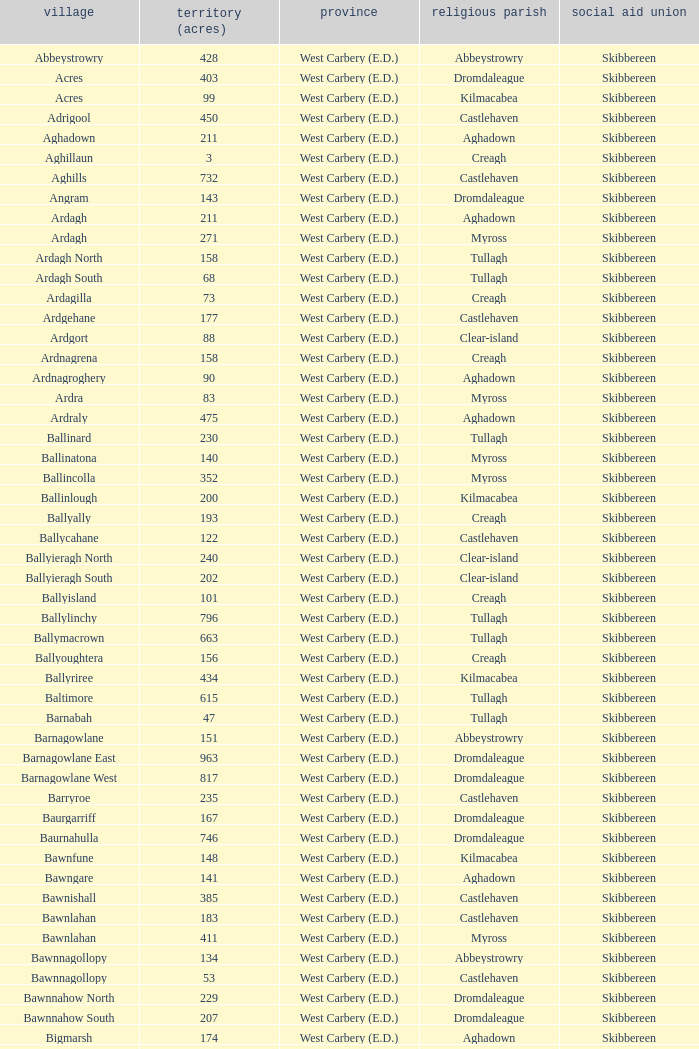What are the Baronies when the area (in acres) is 276? West Carbery (E.D.). 